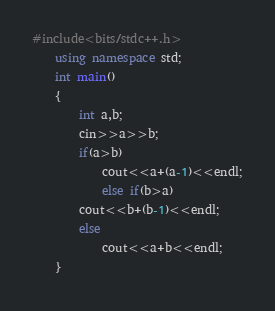<code> <loc_0><loc_0><loc_500><loc_500><_C++_>#include<bits/stdc++.h>
    using namespace std;
    int main()
    {
        int a,b;
        cin>>a>>b;
        if(a>b)
            cout<<a+(a-1)<<endl;
            else if(b>a)
        cout<<b+(b-1)<<endl;
        else
            cout<<a+b<<endl;
    }
</code> 